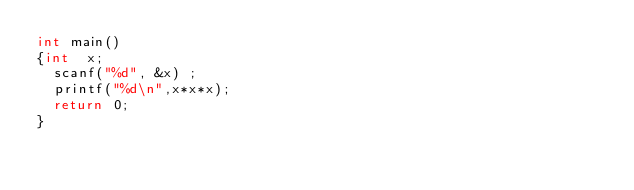<code> <loc_0><loc_0><loc_500><loc_500><_C_>int main()
{int  x;
  scanf("%d", &x) ;
  printf("%d\n",x*x*x);
  return 0;
}

</code> 